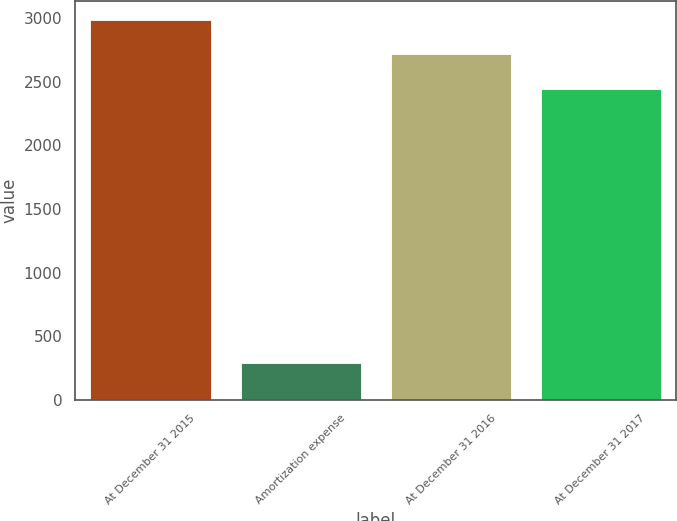<chart> <loc_0><loc_0><loc_500><loc_500><bar_chart><fcel>At December 31 2015<fcel>Amortization expense<fcel>At December 31 2016<fcel>At December 31 2017<nl><fcel>2986.8<fcel>291<fcel>2718<fcel>2445<nl></chart> 